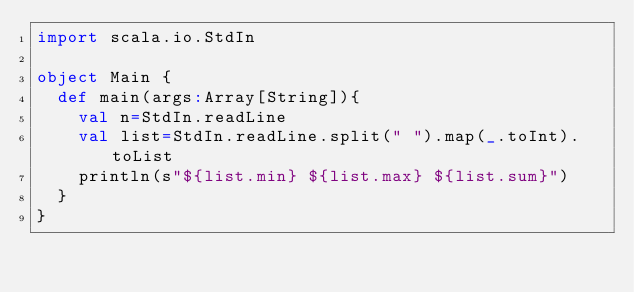Convert code to text. <code><loc_0><loc_0><loc_500><loc_500><_Scala_>import scala.io.StdIn

object Main {
  def main(args:Array[String]){
    val n=StdIn.readLine
    val list=StdIn.readLine.split(" ").map(_.toInt).toList
    println(s"${list.min} ${list.max} ${list.sum}")
  }
}</code> 